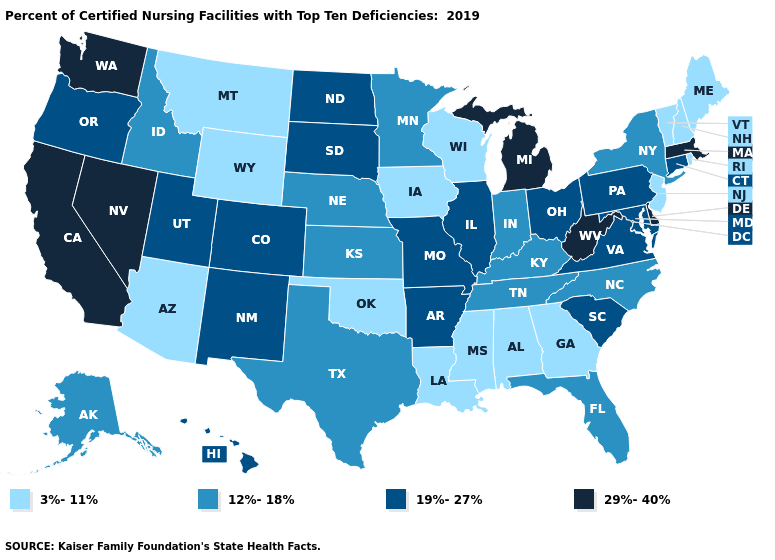What is the highest value in the MidWest ?
Give a very brief answer. 29%-40%. Is the legend a continuous bar?
Give a very brief answer. No. Does Mississippi have a higher value than Connecticut?
Write a very short answer. No. Does Pennsylvania have the same value as Connecticut?
Be succinct. Yes. Does the first symbol in the legend represent the smallest category?
Keep it brief. Yes. Among the states that border Tennessee , which have the highest value?
Answer briefly. Arkansas, Missouri, Virginia. Which states hav the highest value in the West?
Concise answer only. California, Nevada, Washington. Name the states that have a value in the range 29%-40%?
Concise answer only. California, Delaware, Massachusetts, Michigan, Nevada, Washington, West Virginia. Which states have the lowest value in the West?
Be succinct. Arizona, Montana, Wyoming. What is the value of Oklahoma?
Keep it brief. 3%-11%. Among the states that border Rhode Island , which have the highest value?
Keep it brief. Massachusetts. Does Nevada have the highest value in the USA?
Keep it brief. Yes. What is the highest value in the USA?
Quick response, please. 29%-40%. What is the value of Alaska?
Answer briefly. 12%-18%. Name the states that have a value in the range 12%-18%?
Give a very brief answer. Alaska, Florida, Idaho, Indiana, Kansas, Kentucky, Minnesota, Nebraska, New York, North Carolina, Tennessee, Texas. 